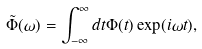Convert formula to latex. <formula><loc_0><loc_0><loc_500><loc_500>\tilde { \Phi } ( \omega ) = \int _ { - \infty } ^ { \infty } d t \Phi ( t ) \exp ( i \omega t ) ,</formula> 